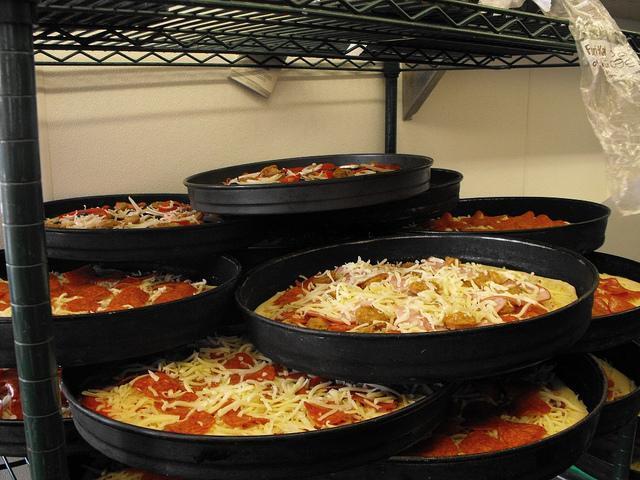How many bowls can be seen?
Give a very brief answer. 6. How many pizzas are there?
Give a very brief answer. 7. 